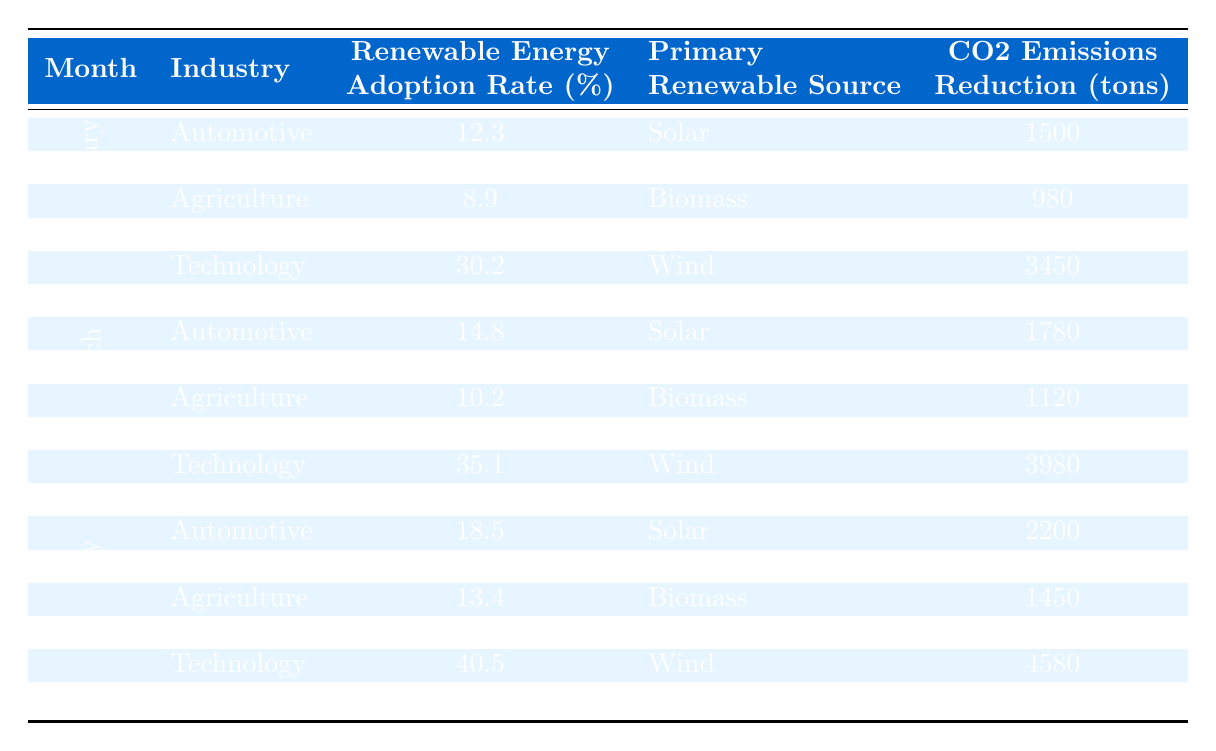What is the renewable energy adoption rate for the Technology industry in May? In the table, under the month of May, the adoption rate for the Technology industry is explicitly stated as 37.9%.
Answer: 37.9% Which industry had the highest CO2 emissions reduction in April? Looking at the CO2 emissions reduction values for April, the Technology industry shows a reduction of 3980 tons, which is higher than the Automotive (1950 tons) and Agriculture (1280 tons) industries.
Answer: Technology What is the average renewable energy adoption rate across all industries for June? To find the average for June, we take the rates for all three industries: Automotive (20.1%), Technology (40.5%), Agriculture (15.7%). Summing these gives 20.1 + 40.5 + 15.7 = 76.3%. Dividing by the number of industries (3), the average is 76.3 / 3 = 25.43%.
Answer: 25.43% Did the Agricultural industry have an improvement in its renewable energy adoption rate from January to June? In January, the rate for Agriculture was 8.9%, and in June it was 15.7%. Since 15.7% is greater than 8.9%, this indicates an improvement in the adoption rate.
Answer: Yes What was the total CO2 emissions reduction from all industries in February? We sum the CO2 reductions for each industry in February: Automotive (1620 tons) + Technology (3450 tons) + Agriculture (1050 tons) = 1620 + 3450 + 1050 = 6120 tons.
Answer: 6120 tons Which month showed the lowest renewable energy adoption rate for the Automotive industry? The table shows the adoption rates for the Automotive industry across the months: January (12.3%), February (13.1%), March (14.8%), April (16.2%), May (18.5%), and June (20.1%). The lowest rate is found in January at 12.3%.
Answer: January How much CO2 emissions reduction was achieved by the Technology industry from January to March? The reduction values for Technology are: January (3200 tons), February (3450 tons), and March (3700 tons). To find the total reduction over these months, we sum these: 3200 + 3450 + 3700 = 10350 tons.
Answer: 10350 tons What percentage increase in renewable energy adoption rate did the Automotive industry experience from March to April? The rates are March (14.8%) and April (16.2%). The increase is 16.2 - 14.8 = 1.4%. To find the percentage increase, divide by the March rate and multiply by 100: (1.4 / 14.8) * 100 ≈ 9.46%.
Answer: Approximately 9.46% Which industry consistently used Wind as the primary renewable source? The table indicates that the Technology industry used Wind as its primary renewable source throughout all months listed, while other industries used different sources.
Answer: Technology Was the CO2 emissions reduction from the Technology industry higher than both Automotive and Agriculture in June? In June, the Technology industry had a reduction of 4580 tons, while Automotive had 2380 tons and Agriculture had 1690 tons. Since 4580 tons is greater than both 2380 tons and 1690 tons, the statement is true.
Answer: Yes 